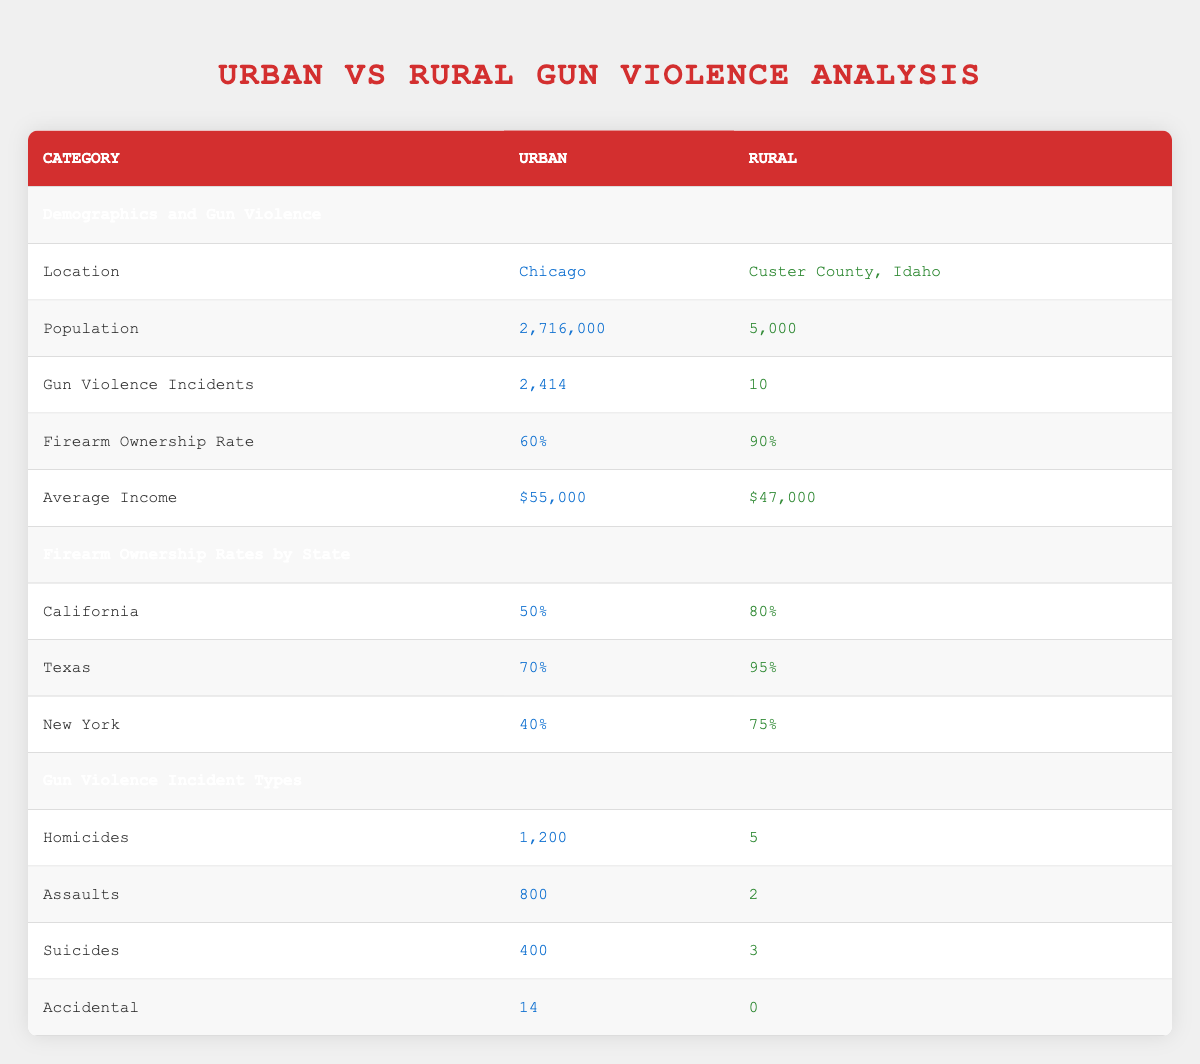What is the total population of Chicago and Custer County, Idaho? To find the total population, add the populations of both locations: Chicago has a population of 2,716,000 and Custer County has 5,000. So, total population = 2,716,000 + 5,000 = 2,721,000.
Answer: 2,721,000 How many gun violence incidents occurred in Chicago? The table specifies that there were 2,414 gun violence incidents in Chicago.
Answer: 2,414 What is the firearm ownership rate in Custer County, Idaho? According to the table, the firearm ownership rate in Custer County is 90%.
Answer: 90% Are there more homicides in urban or rural areas? The table shows 1,200 homicides in urban areas (Chicago) and 5 in rural areas (Custer County). Since 1,200 is greater than 5, it indicates urban areas have more homicides.
Answer: Yes What is the average income gap between urban and rural areas in this data? To find the average income gap, subtract the average income in Custer County ($47,000) from that in Chicago ($55,000): $55,000 - $47,000 = $8,000. The average income in urban areas is higher by this amount.
Answer: $8,000 What percentage of gun violence incidents in Chicago are homicides? To find this, divide the number of homicides in Chicago (1,200) by the total gun violence incidents (2,414). The percentage is calculated as (1,200 / 2,414) * 100, which is approximately 49.7%. Therefore, almost 50% of the gun violence incidents in Chicago are homicides.
Answer: Approximately 49.7% Which state has the highest rural firearm ownership percentage according to the table? The table shows Texas has the highest rural firearm ownership percentage at 95%.
Answer: Texas What is the total number of gun violence incidents categorized as assaults in both urban and rural areas? In urban areas, there are 800 assaults, and in rural areas, there are 2 assaults. To find the total, add these two numbers: 800 + 2 = 802.
Answer: 802 Is the average income in urban areas higher than in rural areas? The average income in urban areas (Chicago) is $55,000, whereas in rural areas (Custer County) it is $47,000. Since $55,000 is greater than $47,000, the statement is true.
Answer: Yes 